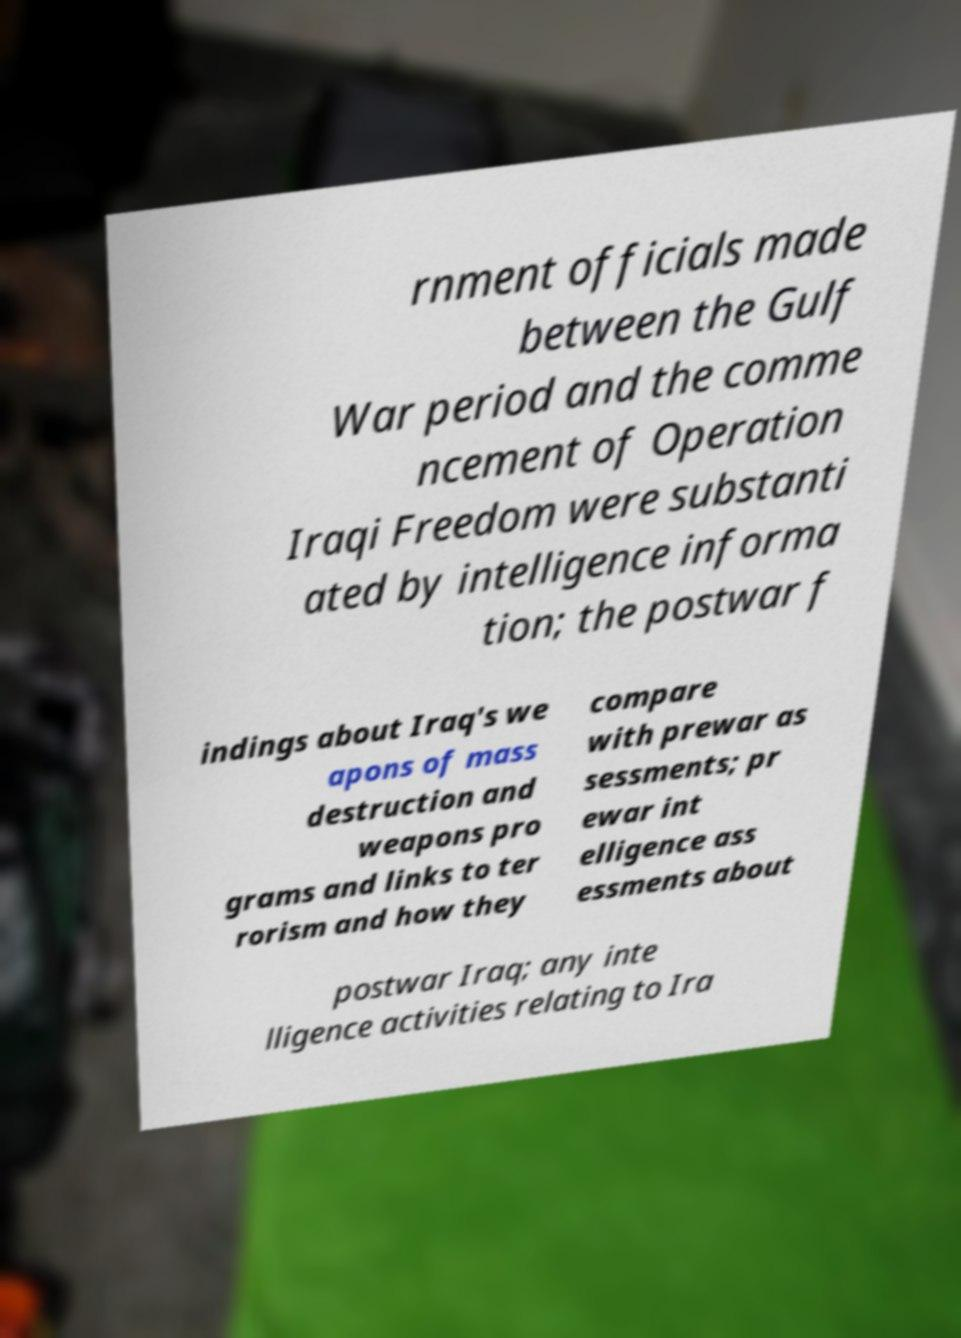What messages or text are displayed in this image? I need them in a readable, typed format. rnment officials made between the Gulf War period and the comme ncement of Operation Iraqi Freedom were substanti ated by intelligence informa tion; the postwar f indings about Iraq's we apons of mass destruction and weapons pro grams and links to ter rorism and how they compare with prewar as sessments; pr ewar int elligence ass essments about postwar Iraq; any inte lligence activities relating to Ira 